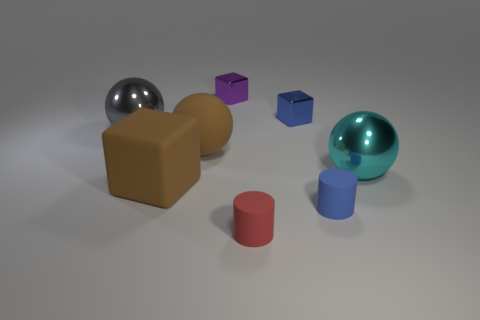Add 1 blue cubes. How many objects exist? 9 Subtract all blocks. How many objects are left? 5 Add 4 brown metal balls. How many brown metal balls exist? 4 Subtract 0 green blocks. How many objects are left? 8 Subtract all large red matte spheres. Subtract all purple things. How many objects are left? 7 Add 2 brown rubber things. How many brown rubber things are left? 4 